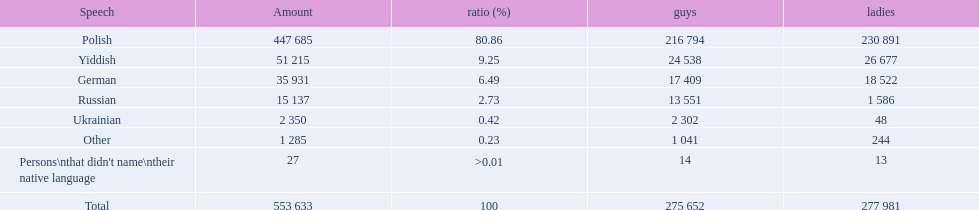What language makes a majority Polish. What the the total number of speakers? 553 633. 